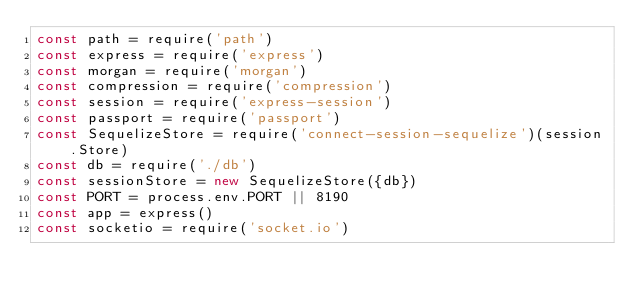Convert code to text. <code><loc_0><loc_0><loc_500><loc_500><_JavaScript_>const path = require('path')
const express = require('express')
const morgan = require('morgan')
const compression = require('compression')
const session = require('express-session')
const passport = require('passport')
const SequelizeStore = require('connect-session-sequelize')(session.Store)
const db = require('./db')
const sessionStore = new SequelizeStore({db})
const PORT = process.env.PORT || 8190
const app = express()
const socketio = require('socket.io')</code> 